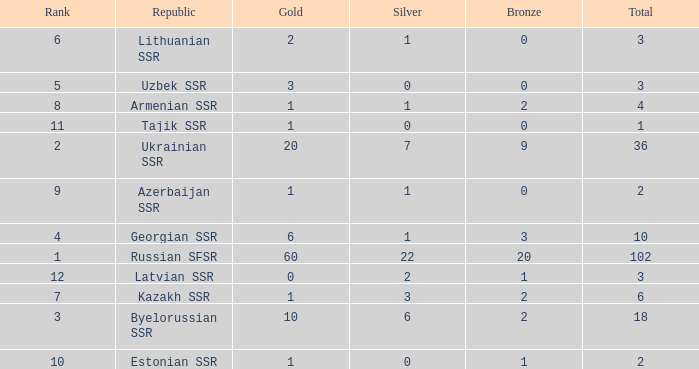What is the average total for teams with more than 1 gold, ranked over 3 and more than 3 bronze? None. 